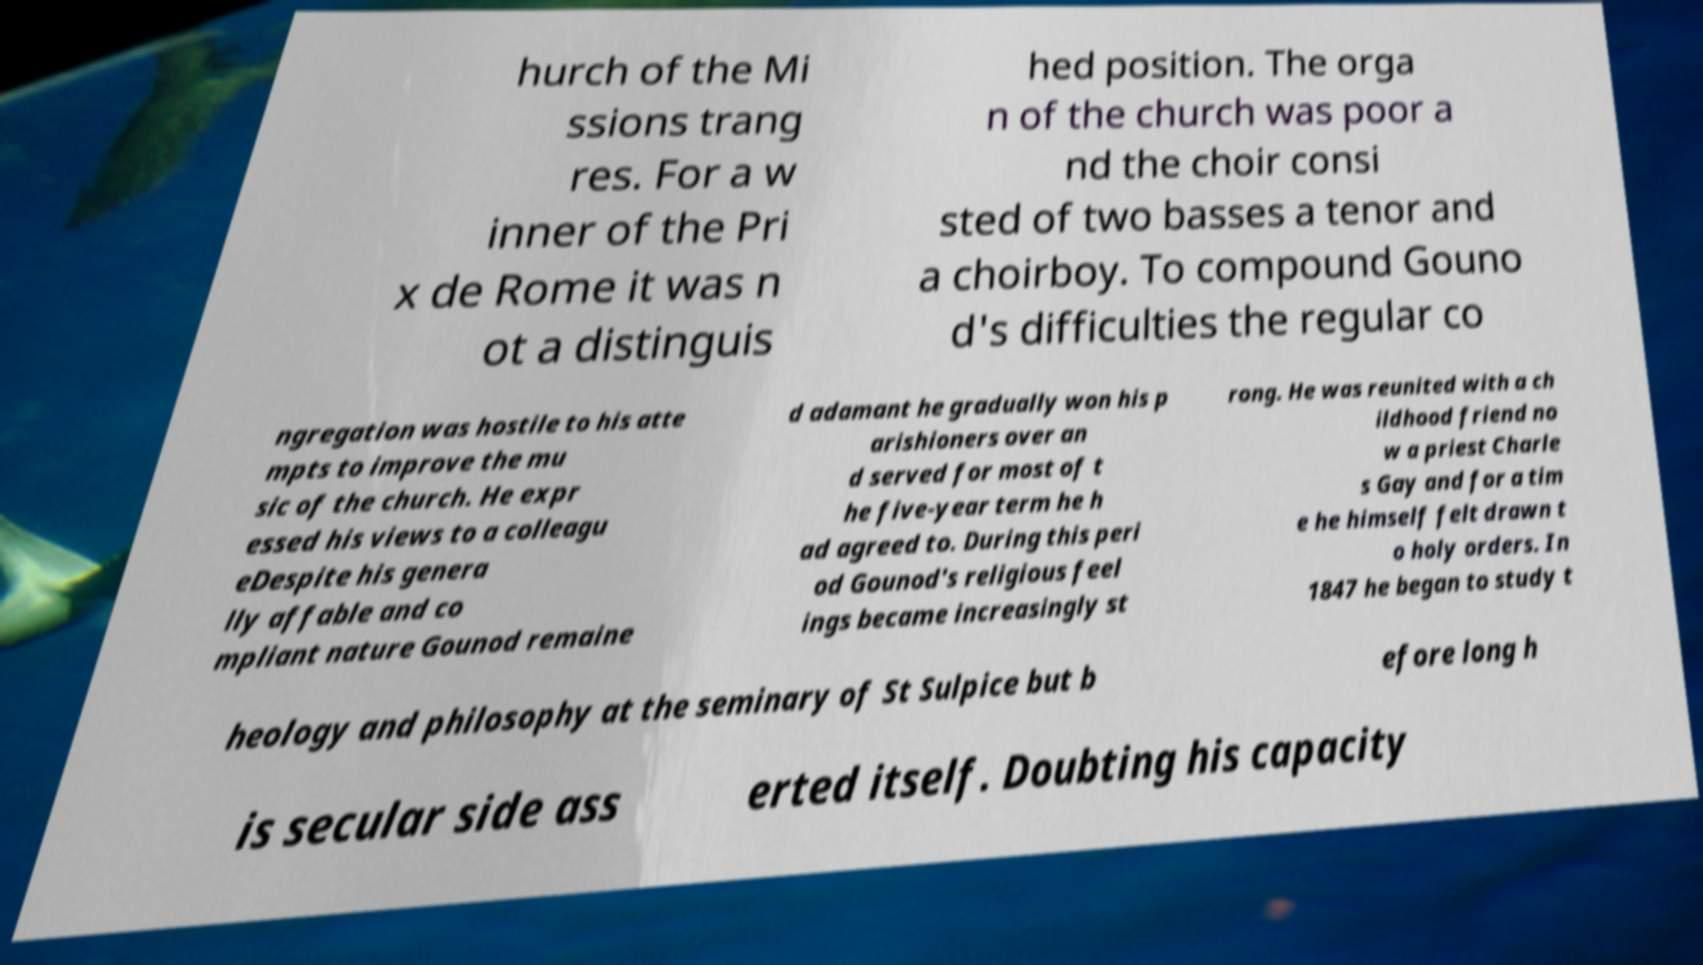Please identify and transcribe the text found in this image. hurch of the Mi ssions trang res. For a w inner of the Pri x de Rome it was n ot a distinguis hed position. The orga n of the church was poor a nd the choir consi sted of two basses a tenor and a choirboy. To compound Gouno d's difficulties the regular co ngregation was hostile to his atte mpts to improve the mu sic of the church. He expr essed his views to a colleagu eDespite his genera lly affable and co mpliant nature Gounod remaine d adamant he gradually won his p arishioners over an d served for most of t he five-year term he h ad agreed to. During this peri od Gounod's religious feel ings became increasingly st rong. He was reunited with a ch ildhood friend no w a priest Charle s Gay and for a tim e he himself felt drawn t o holy orders. In 1847 he began to study t heology and philosophy at the seminary of St Sulpice but b efore long h is secular side ass erted itself. Doubting his capacity 